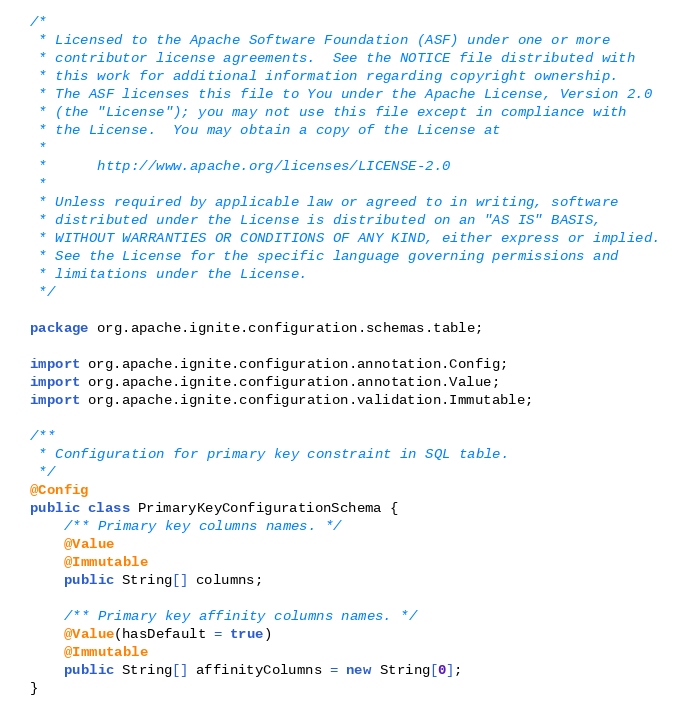<code> <loc_0><loc_0><loc_500><loc_500><_Java_>/*
 * Licensed to the Apache Software Foundation (ASF) under one or more
 * contributor license agreements.  See the NOTICE file distributed with
 * this work for additional information regarding copyright ownership.
 * The ASF licenses this file to You under the Apache License, Version 2.0
 * (the "License"); you may not use this file except in compliance with
 * the License.  You may obtain a copy of the License at
 *
 *      http://www.apache.org/licenses/LICENSE-2.0
 *
 * Unless required by applicable law or agreed to in writing, software
 * distributed under the License is distributed on an "AS IS" BASIS,
 * WITHOUT WARRANTIES OR CONDITIONS OF ANY KIND, either express or implied.
 * See the License for the specific language governing permissions and
 * limitations under the License.
 */

package org.apache.ignite.configuration.schemas.table;

import org.apache.ignite.configuration.annotation.Config;
import org.apache.ignite.configuration.annotation.Value;
import org.apache.ignite.configuration.validation.Immutable;

/**
 * Configuration for primary key constraint in SQL table.
 */
@Config
public class PrimaryKeyConfigurationSchema {
    /** Primary key columns names. */
    @Value
    @Immutable
    public String[] columns;

    /** Primary key affinity columns names. */
    @Value(hasDefault = true)
    @Immutable
    public String[] affinityColumns = new String[0];
}
</code> 